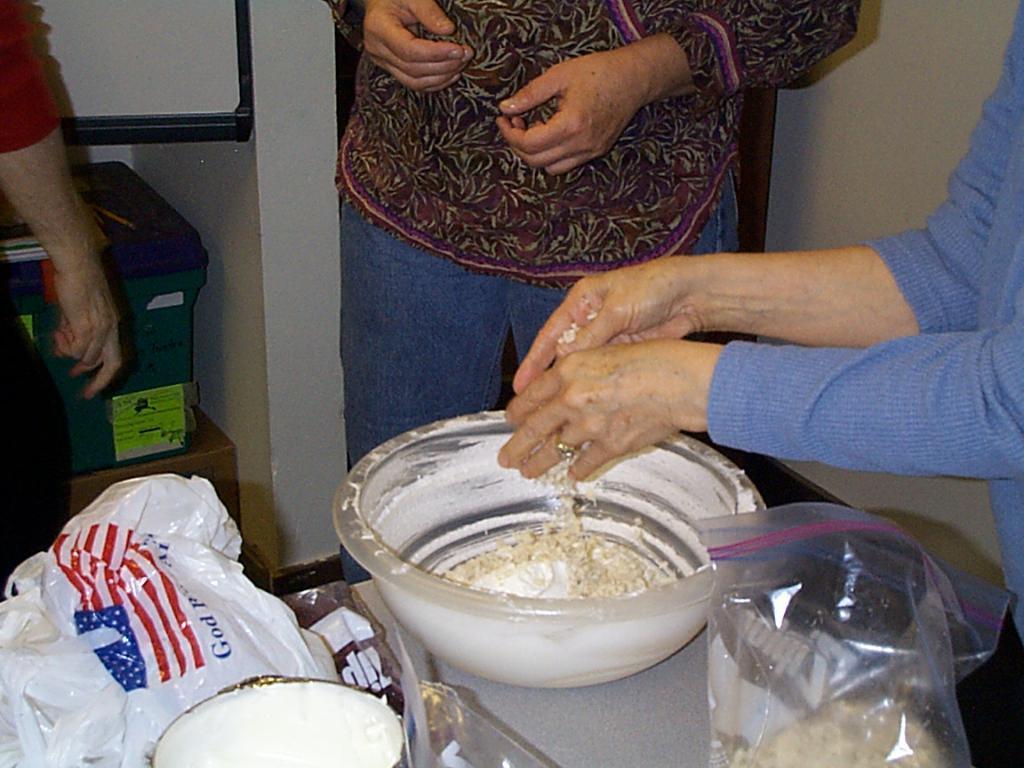In one or two sentences, can you explain what this image depicts? In this image we can see a woman standing beside a table containing a bowl with some food, some covers and a bowl on it. We can also see some people standing, a wall and a container placed on the surface. 